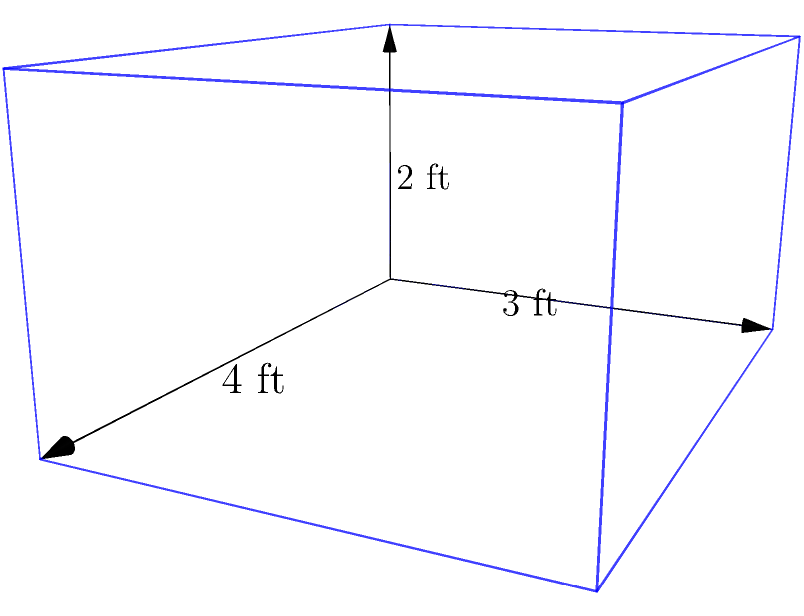At the playground, you're helping to build a new sandbox for the younger children. The sandbox is shaped like a rectangular prism with a length of 4 feet, width of 3 feet, and depth of 2 feet. How many cubic feet of sand will be needed to fill this sandbox completely? To find the volume of the rectangular prism-shaped sandbox, we need to use the formula:

$$V = l \times w \times h$$

Where:
$V$ = volume
$l$ = length
$w$ = width
$h$ = height (or depth in this case)

Let's plug in the given dimensions:

$l = 4$ feet
$w = 3$ feet
$h = 2$ feet

Now, let's calculate:

$$V = 4 \text{ ft} \times 3 \text{ ft} \times 2 \text{ ft}$$
$$V = 24 \text{ cubic feet}$$

Therefore, the sandbox will need 24 cubic feet of sand to be filled completely.
Answer: 24 cubic feet 